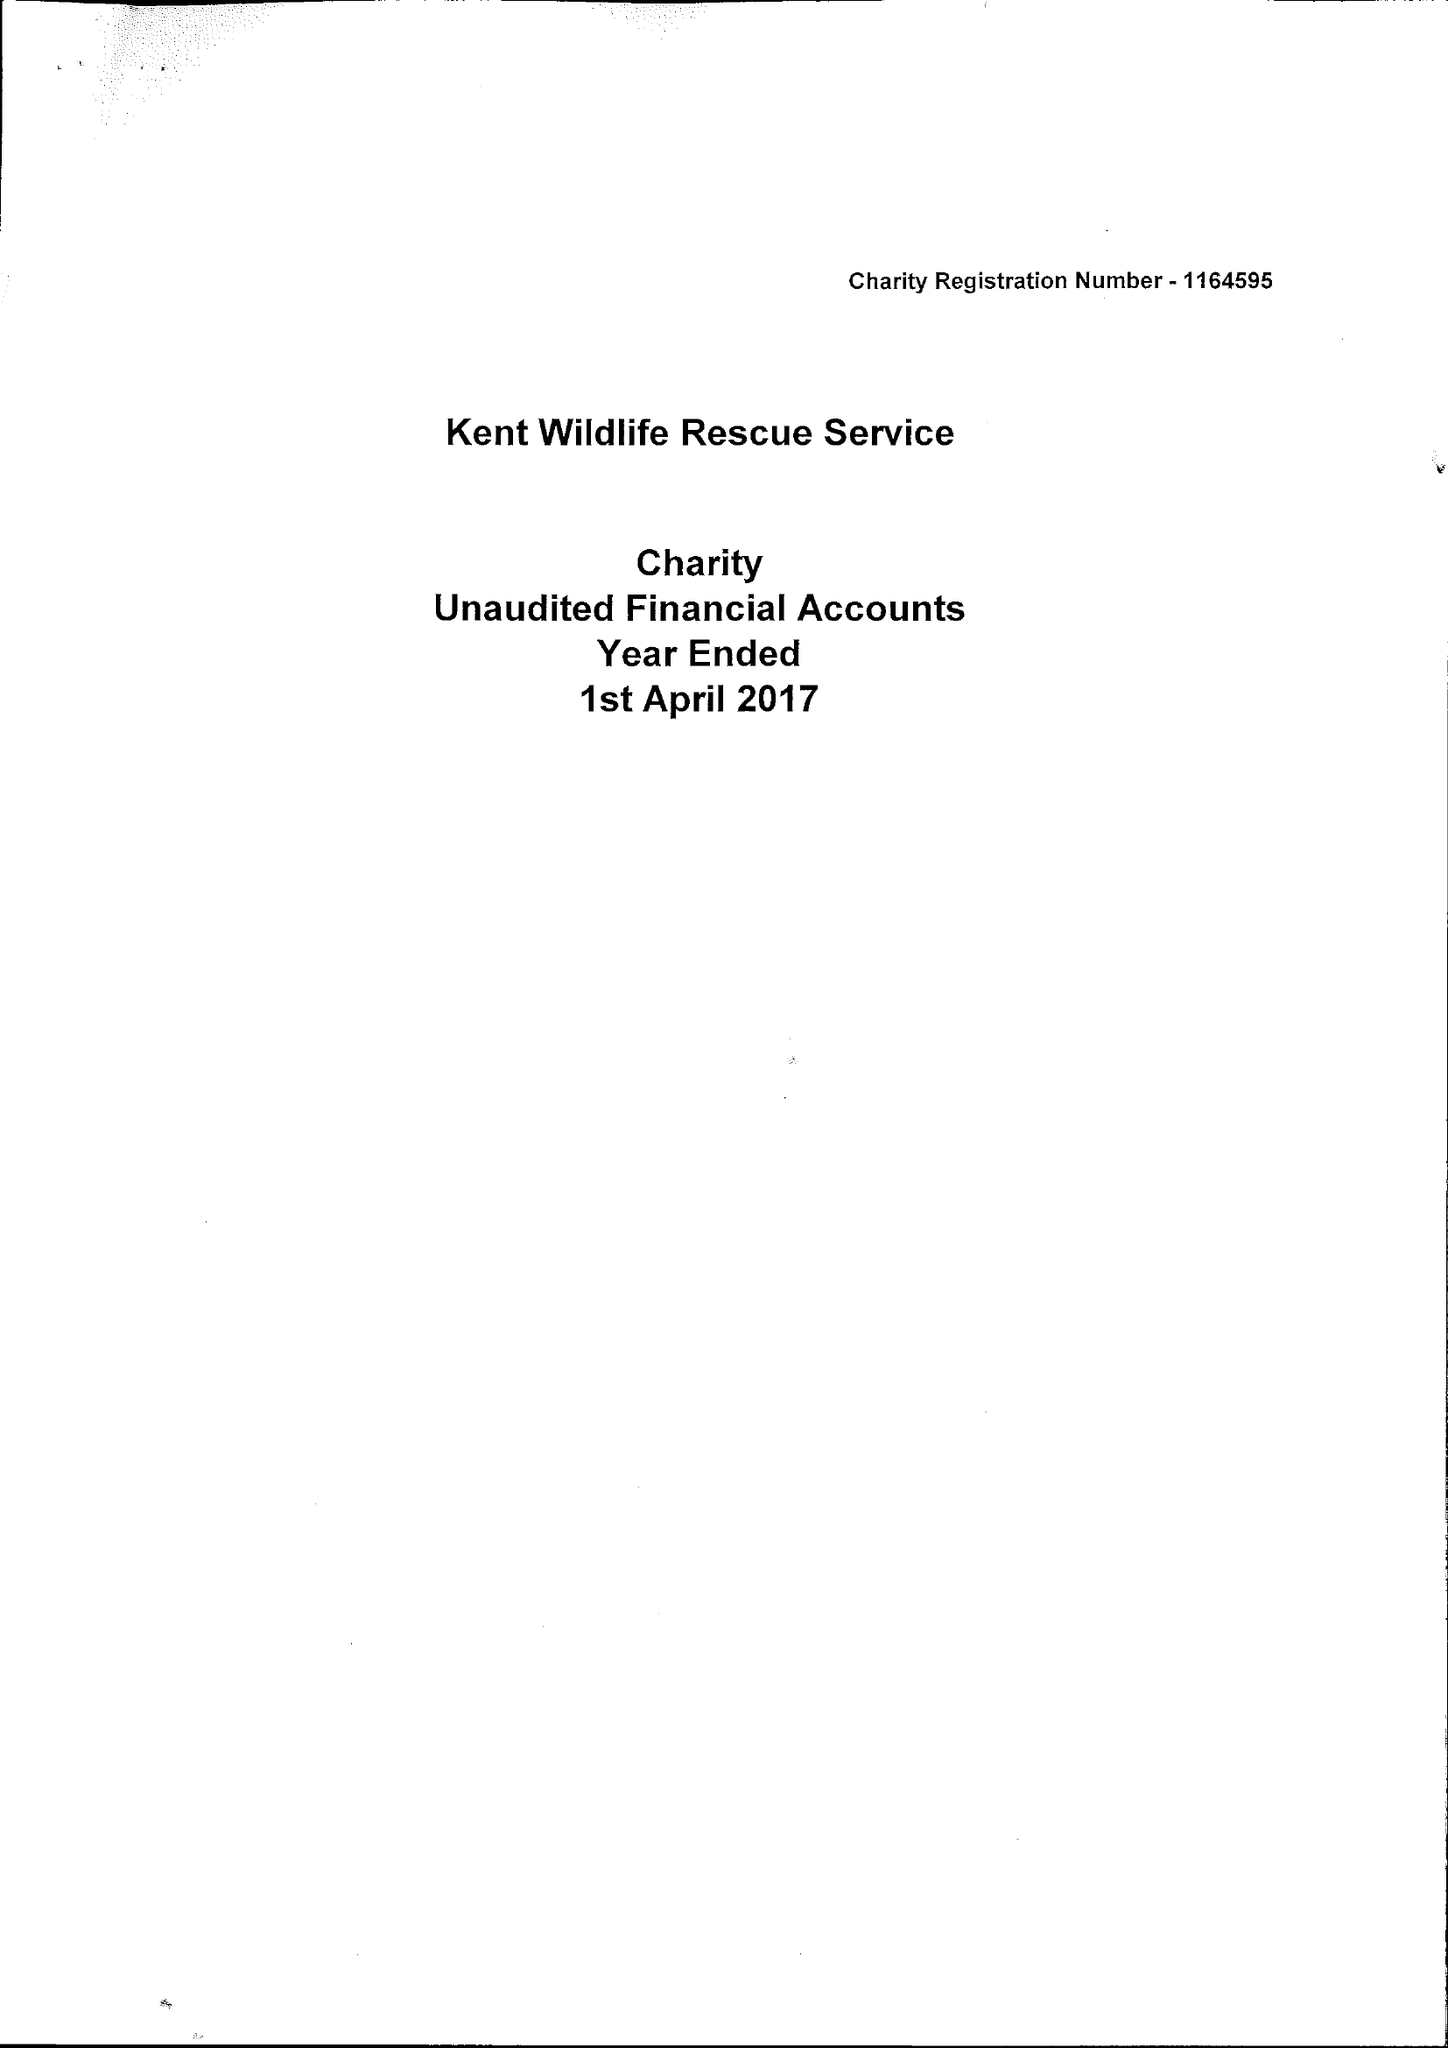What is the value for the income_annually_in_british_pounds?
Answer the question using a single word or phrase. 15605.00 